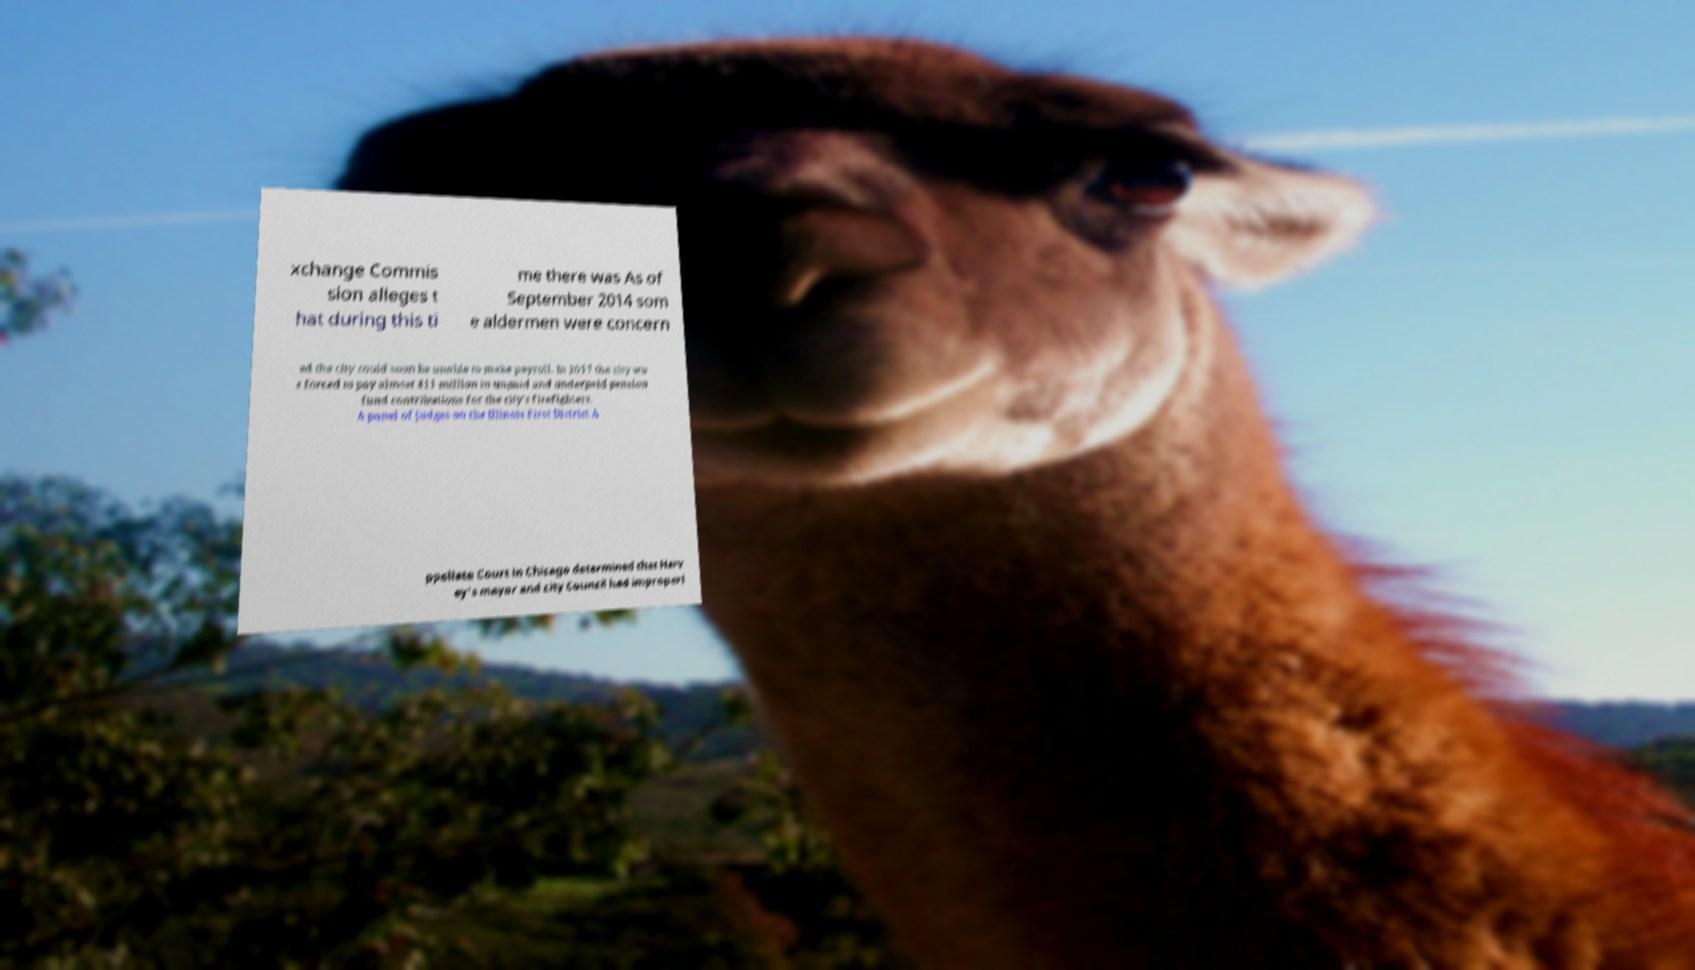I need the written content from this picture converted into text. Can you do that? xchange Commis sion alleges t hat during this ti me there was As of September 2014 som e aldermen were concern ed the city could soon be unable to make payroll. In 2017 the city wa s forced to pay almost $11 million in unpaid and underpaid pension fund contributions for the city's firefighters. A panel of judges on the Illinois First District A ppellate Court in Chicago determined that Harv ey's mayor and city Council had improperl 